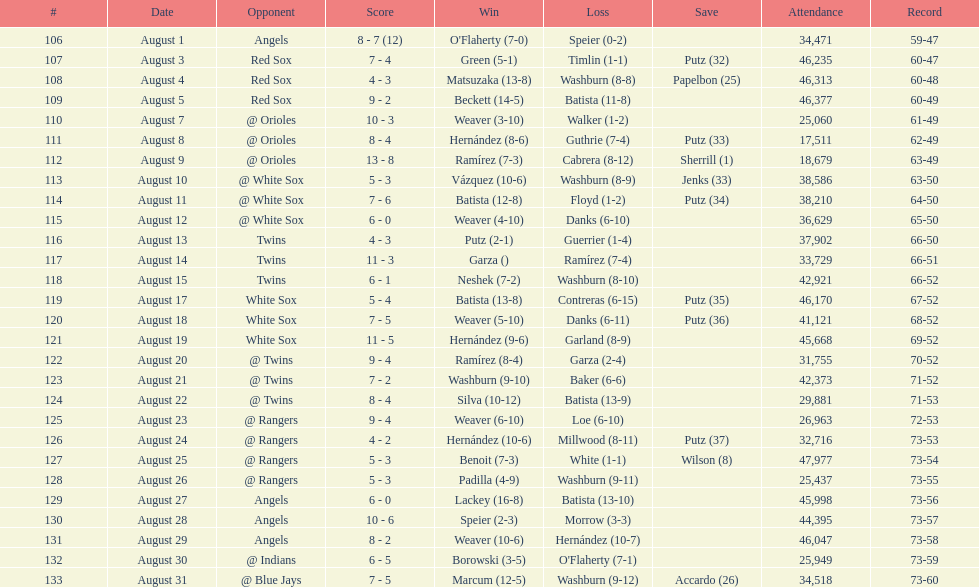Quantity of successes within the period 5. 